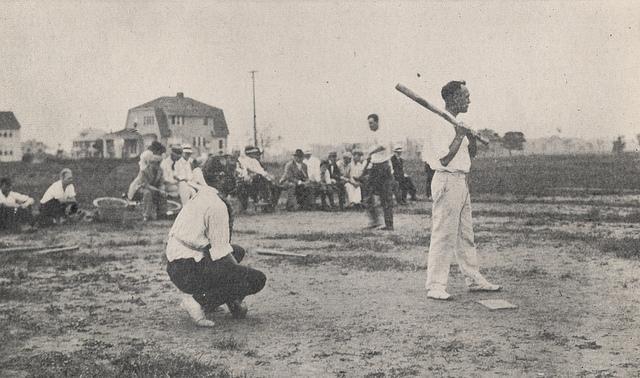How many people are visible?
Give a very brief answer. 5. 